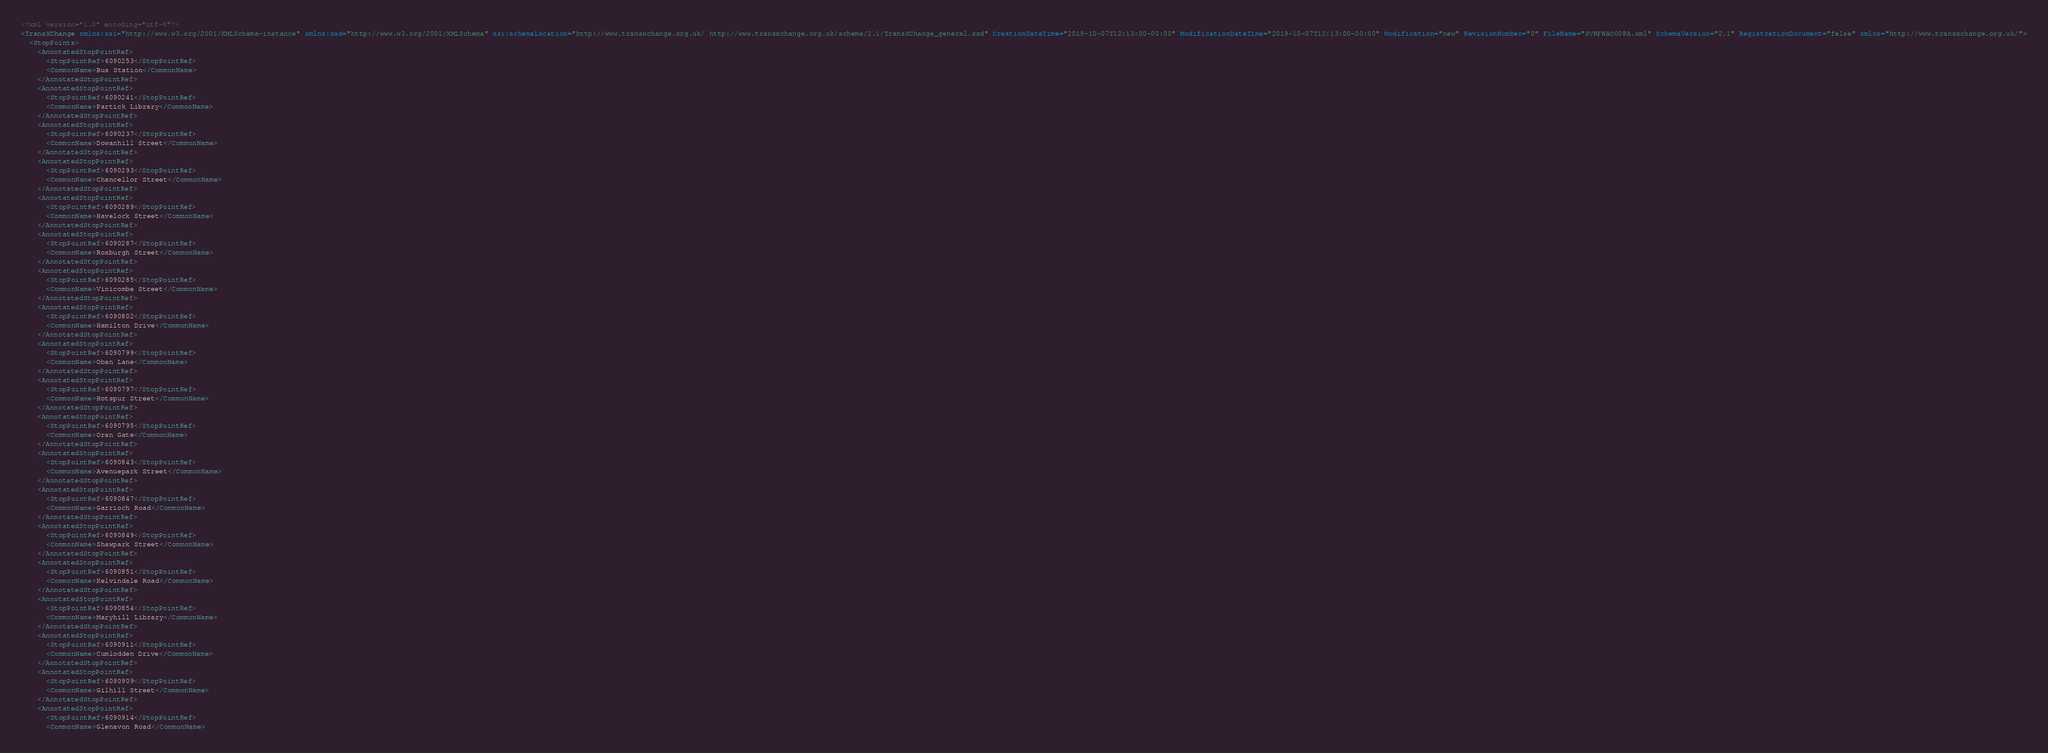<code> <loc_0><loc_0><loc_500><loc_500><_XML_><?xml version="1.0" encoding="utf-8"?>
<TransXChange xmlns:xsi="http://www.w3.org/2001/XMLSchema-instance" xmlns:xsd="http://www.w3.org/2001/XMLSchema" xsi:schemaLocation="http://www.transxchange.org.uk/ http://www.transxchange.org.uk/schema/2.1/TransXChange_general.xsd" CreationDateTime="2019-10-07T12:13:00-00:00" ModificationDateTime="2019-10-07T12:13:00-00:00" Modification="new" RevisionNumber="0" FileName="SVRFWAO008A.xml" SchemaVersion="2.1" RegistrationDocument="false" xmlns="http://www.transxchange.org.uk/">
  <StopPoints>
    <AnnotatedStopPointRef>
      <StopPointRef>6090253</StopPointRef>
      <CommonName>Bus Station</CommonName>
    </AnnotatedStopPointRef>
    <AnnotatedStopPointRef>
      <StopPointRef>6090241</StopPointRef>
      <CommonName>Partick Library</CommonName>
    </AnnotatedStopPointRef>
    <AnnotatedStopPointRef>
      <StopPointRef>6090237</StopPointRef>
      <CommonName>Dowanhill Street</CommonName>
    </AnnotatedStopPointRef>
    <AnnotatedStopPointRef>
      <StopPointRef>6090293</StopPointRef>
      <CommonName>Chancellor Street</CommonName>
    </AnnotatedStopPointRef>
    <AnnotatedStopPointRef>
      <StopPointRef>6090289</StopPointRef>
      <CommonName>Havelock Street</CommonName>
    </AnnotatedStopPointRef>
    <AnnotatedStopPointRef>
      <StopPointRef>6090287</StopPointRef>
      <CommonName>Roxburgh Street</CommonName>
    </AnnotatedStopPointRef>
    <AnnotatedStopPointRef>
      <StopPointRef>6090285</StopPointRef>
      <CommonName>Vinicombe Street</CommonName>
    </AnnotatedStopPointRef>
    <AnnotatedStopPointRef>
      <StopPointRef>6090802</StopPointRef>
      <CommonName>Hamilton Drive</CommonName>
    </AnnotatedStopPointRef>
    <AnnotatedStopPointRef>
      <StopPointRef>6090799</StopPointRef>
      <CommonName>Oban Lane</CommonName>
    </AnnotatedStopPointRef>
    <AnnotatedStopPointRef>
      <StopPointRef>6090797</StopPointRef>
      <CommonName>Hotspur Street</CommonName>
    </AnnotatedStopPointRef>
    <AnnotatedStopPointRef>
      <StopPointRef>6090795</StopPointRef>
      <CommonName>Oran Gate</CommonName>
    </AnnotatedStopPointRef>
    <AnnotatedStopPointRef>
      <StopPointRef>6090843</StopPointRef>
      <CommonName>Avenuepark Street</CommonName>
    </AnnotatedStopPointRef>
    <AnnotatedStopPointRef>
      <StopPointRef>6090847</StopPointRef>
      <CommonName>Garrioch Road</CommonName>
    </AnnotatedStopPointRef>
    <AnnotatedStopPointRef>
      <StopPointRef>6090849</StopPointRef>
      <CommonName>Shawpark Street</CommonName>
    </AnnotatedStopPointRef>
    <AnnotatedStopPointRef>
      <StopPointRef>6090851</StopPointRef>
      <CommonName>Kelvindale Road</CommonName>
    </AnnotatedStopPointRef>
    <AnnotatedStopPointRef>
      <StopPointRef>6090854</StopPointRef>
      <CommonName>Maryhill Library</CommonName>
    </AnnotatedStopPointRef>
    <AnnotatedStopPointRef>
      <StopPointRef>6090911</StopPointRef>
      <CommonName>Cumlodden Drive</CommonName>
    </AnnotatedStopPointRef>
    <AnnotatedStopPointRef>
      <StopPointRef>6090909</StopPointRef>
      <CommonName>Gilhill Street</CommonName>
    </AnnotatedStopPointRef>
    <AnnotatedStopPointRef>
      <StopPointRef>6090914</StopPointRef>
      <CommonName>Glenavon Road</CommonName></code> 